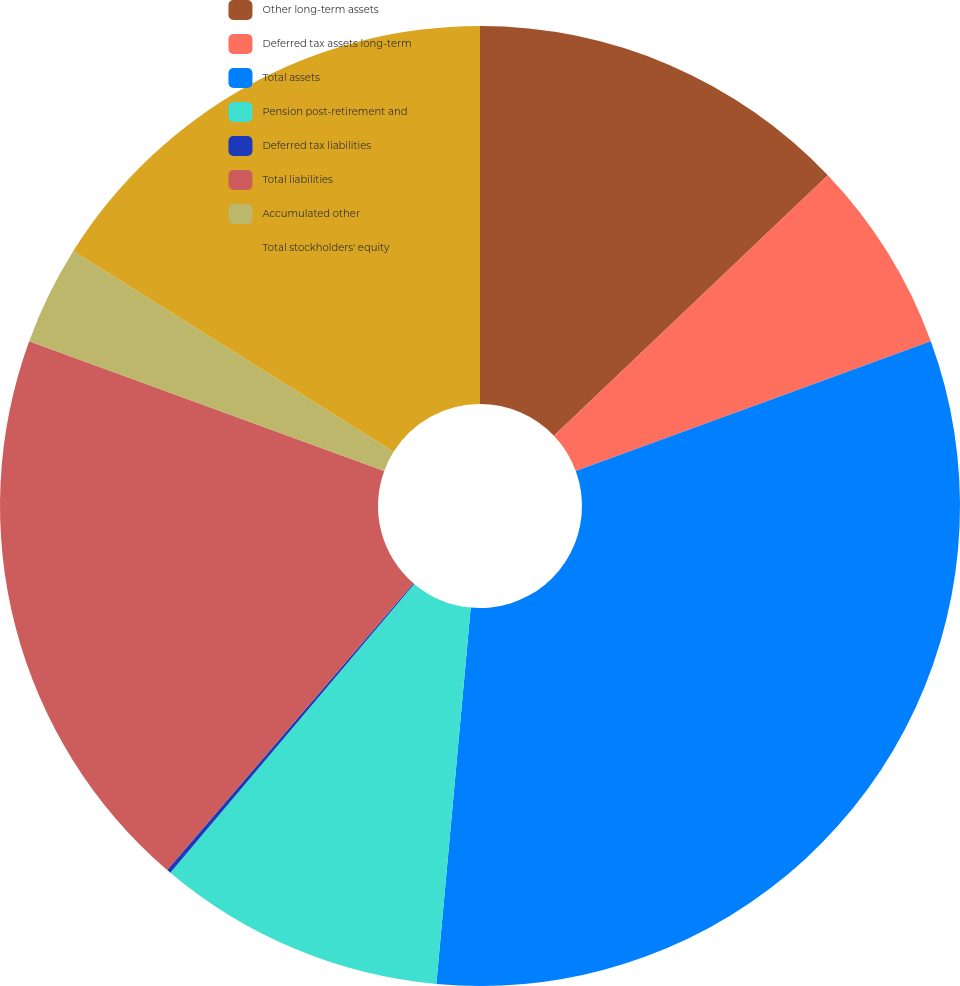Convert chart to OTSL. <chart><loc_0><loc_0><loc_500><loc_500><pie_chart><fcel>Other long-term assets<fcel>Deferred tax assets long-term<fcel>Total assets<fcel>Pension post-retirement and<fcel>Deferred tax liabilities<fcel>Total liabilities<fcel>Accumulated other<fcel>Total stockholders' equity<nl><fcel>12.9%<fcel>6.52%<fcel>32.03%<fcel>9.71%<fcel>0.14%<fcel>19.28%<fcel>3.33%<fcel>16.09%<nl></chart> 